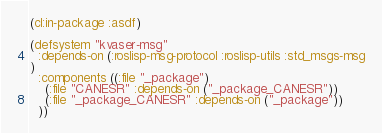Convert code to text. <code><loc_0><loc_0><loc_500><loc_500><_Lisp_>(cl:in-package :asdf)

(defsystem "kvaser-msg"
  :depends-on (:roslisp-msg-protocol :roslisp-utils :std_msgs-msg
)
  :components ((:file "_package")
    (:file "CANESR" :depends-on ("_package_CANESR"))
    (:file "_package_CANESR" :depends-on ("_package"))
  ))</code> 